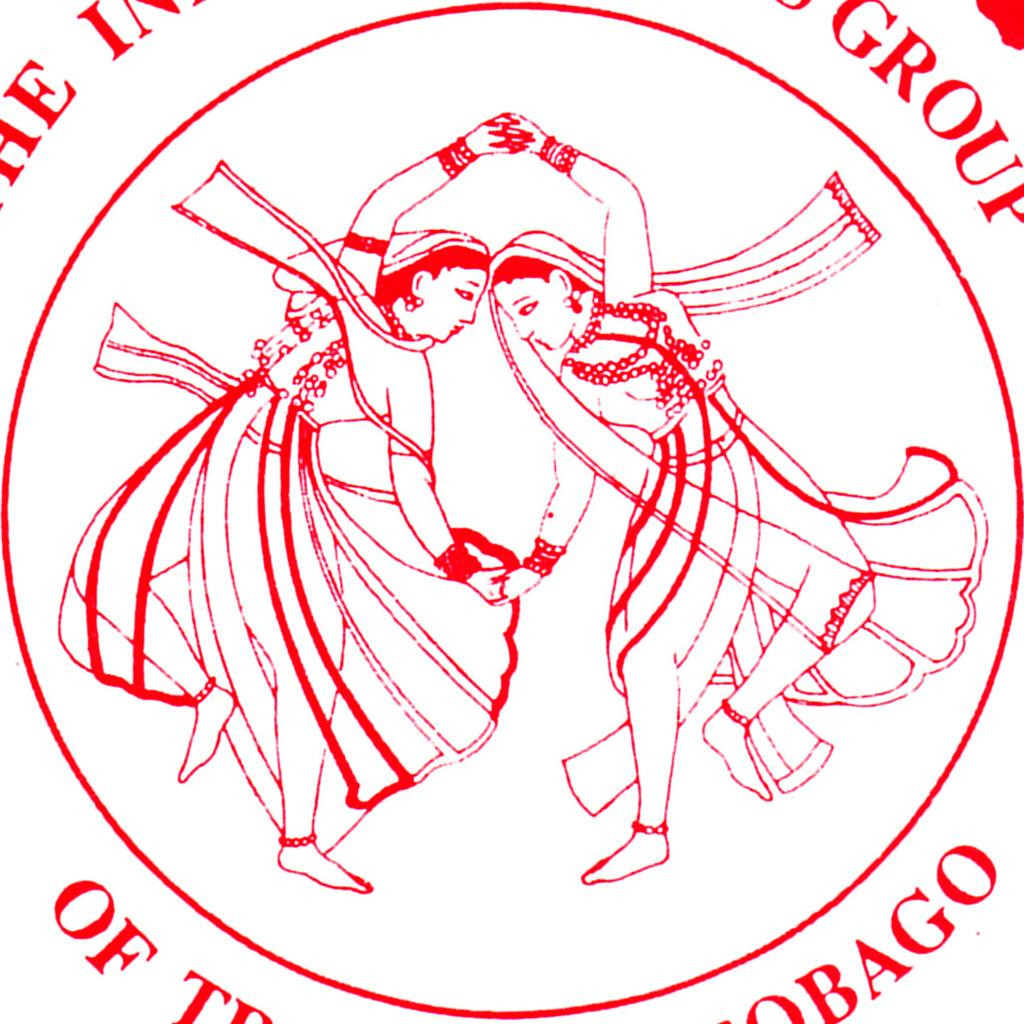What is the main feature of the image? There is a logo in the image. What else can be seen in the image besides the logo? There is some text and depictions of two persons in the middle of the image. What type of frog can be seen sitting on the wire in the image? There is no frog or wire present in the image. 